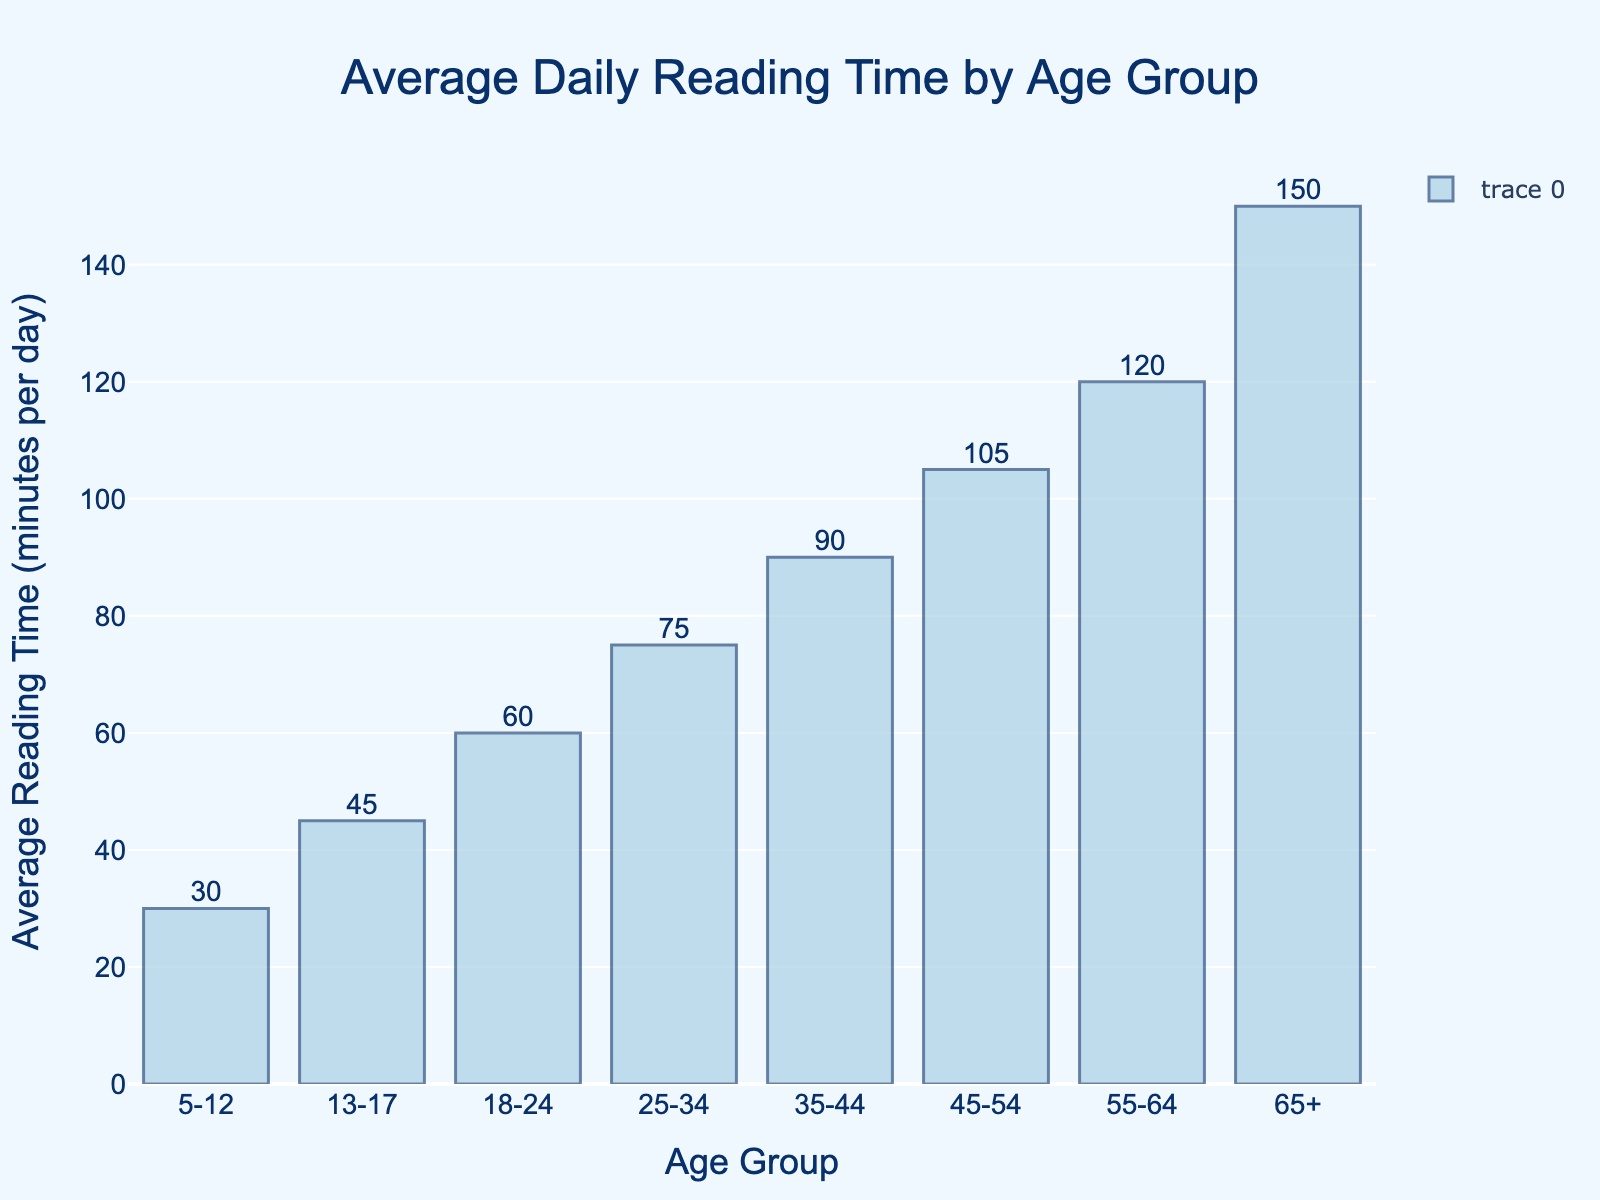What is the title of the histogram? The title is positioned at the top center of the figure. By reading it, you can directly determine what the figure is about.
Answer: Average Daily Reading Time by Age Group Which age group has the highest average reading time? Locate the bar with the highest value on the y-axis. The x-axis label corresponding to this bar gives the age group.
Answer: 65+ Which age group reads for an average of 75 minutes per day? Find the bar with a height corresponding to 75 minutes on the y-axis, and identify its label on the x-axis.
Answer: 25-34 How much more do 65+ readers read compared to 18-24 readers? Find the heights of the bars for the 65+ and 18-24 age groups on the y-axis, then subtract the height of the 18-24 age group from the height of the 65+ group.
Answer: 90 minutes (150 - 60) What is the range of average reading times across all age groups? Identify the maximum and minimum values on the y-axis, then subtract the minimum from the maximum. The minimum is 30 (5-12) and the maximum is 150 (65+).
Answer: 120 minutes (150 - 30) What is the average reading time for age groups below 25? Identify the y-axis values for age groups 5-12, 13-17, and 18-24. Sum these values and then divide by the number of age groups (3).
Answer: 45 minutes ((30 + 45 + 60) / 3) Which age group shows a 30-minute increase in average reading time from 13-17? Identify the average reading time for the 13-17 age group on the y-axis, then find the age group with a reading time 30 minutes higher.
Answer: 18-24 (45 + 30 = 75) What is the difference in average reading time between the 45-54 and 35-44 age groups? Identify the y-axis values for the 45-54 and 35-44 age groups, then subtract the latter from the former.
Answer: 15 minutes (105 - 90) How does the average reading time change as age increases? Observe the trend of the bar heights from left (youngest age group) to right (oldest age group). Determine if the bars are ascending, descending, or show some other pattern.
Answer: It increases with age What is the combined average reading time for groups aged 25-34 and 35-44? Identify the y-axis values for the 25-34 and 35-44 age groups and sum them.
Answer: 165 minutes (75 + 90) 